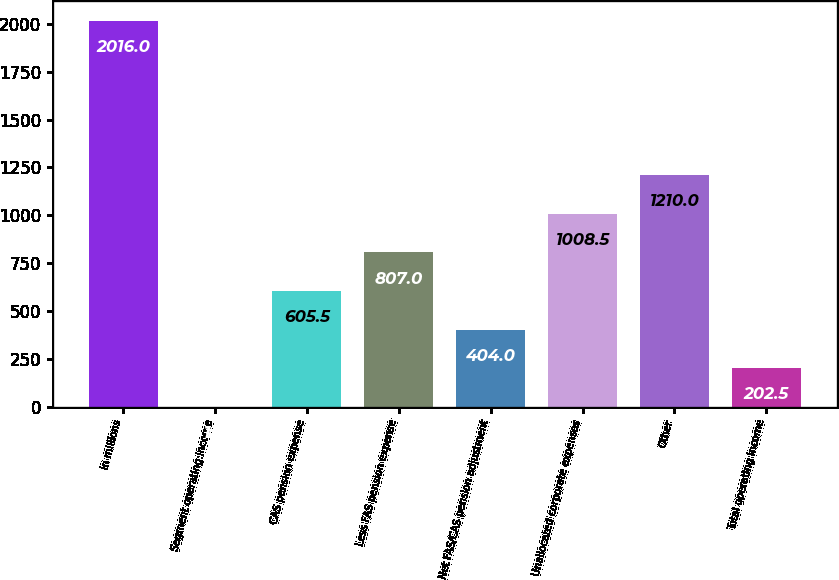Convert chart. <chart><loc_0><loc_0><loc_500><loc_500><bar_chart><fcel>in millions<fcel>Segment operating income<fcel>CAS pension expense<fcel>Less FAS pension expense<fcel>Net FAS/CAS pension adjustment<fcel>Unallocated corporate expenses<fcel>Other<fcel>Total operating income<nl><fcel>2016<fcel>1<fcel>605.5<fcel>807<fcel>404<fcel>1008.5<fcel>1210<fcel>202.5<nl></chart> 